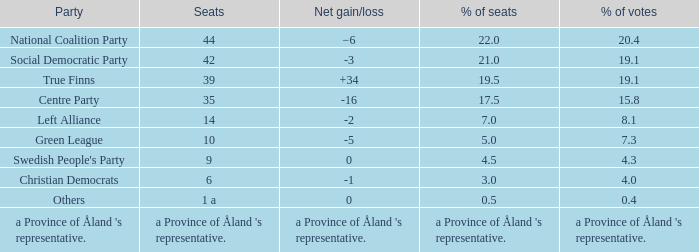Which party possesses a net increase/decrease of -2? Left Alliance. 